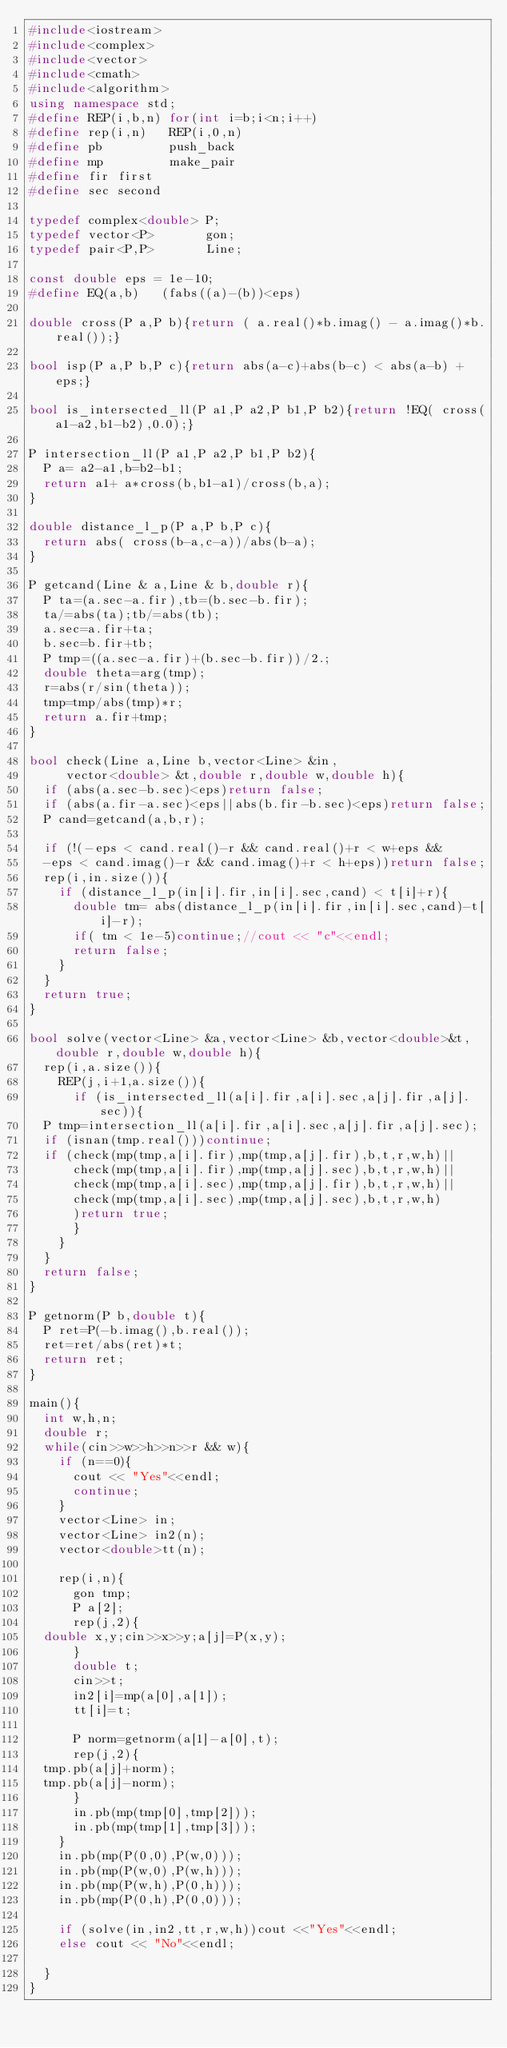<code> <loc_0><loc_0><loc_500><loc_500><_C++_>#include<iostream>
#include<complex>
#include<vector>
#include<cmath>
#include<algorithm>
using namespace std;
#define REP(i,b,n) for(int i=b;i<n;i++)
#define rep(i,n)   REP(i,0,n)
#define pb         push_back
#define mp         make_pair
#define fir first
#define sec second

typedef complex<double> P;
typedef vector<P>       gon;
typedef pair<P,P>       Line;

const double eps = 1e-10;
#define EQ(a,b)   (fabs((a)-(b))<eps)

double cross(P a,P b){return ( a.real()*b.imag() - a.imag()*b.real());}

bool isp(P a,P b,P c){return abs(a-c)+abs(b-c) < abs(a-b) + eps;}

bool is_intersected_ll(P a1,P a2,P b1,P b2){return !EQ( cross(a1-a2,b1-b2),0.0);}

P intersection_ll(P a1,P a2,P b1,P b2){
  P a= a2-a1,b=b2-b1;
  return a1+ a*cross(b,b1-a1)/cross(b,a);
}

double distance_l_p(P a,P b,P c){
  return abs( cross(b-a,c-a))/abs(b-a);
}

P getcand(Line & a,Line & b,double r){
  P ta=(a.sec-a.fir),tb=(b.sec-b.fir);
  ta/=abs(ta);tb/=abs(tb);
  a.sec=a.fir+ta;
  b.sec=b.fir+tb;
  P tmp=((a.sec-a.fir)+(b.sec-b.fir))/2.;
  double theta=arg(tmp);
  r=abs(r/sin(theta));
  tmp=tmp/abs(tmp)*r;
  return a.fir+tmp;
}

bool check(Line a,Line b,vector<Line> &in,
	   vector<double> &t,double r,double w,double h){
  if (abs(a.sec-b.sec)<eps)return false;
  if (abs(a.fir-a.sec)<eps||abs(b.fir-b.sec)<eps)return false;
  P cand=getcand(a,b,r);

  if (!(-eps < cand.real()-r && cand.real()+r < w+eps &&
	-eps < cand.imag()-r && cand.imag()+r < h+eps))return false;
  rep(i,in.size()){
    if (distance_l_p(in[i].fir,in[i].sec,cand) < t[i]+r){
      double tm= abs(distance_l_p(in[i].fir,in[i].sec,cand)-t[i]-r);
      if( tm < 1e-5)continue;//cout << "c"<<endl;
      return false;
    }
  }
  return true;
}

bool solve(vector<Line> &a,vector<Line> &b,vector<double>&t,double r,double w,double h){
  rep(i,a.size()){
    REP(j,i+1,a.size()){
      if (is_intersected_ll(a[i].fir,a[i].sec,a[j].fir,a[j].sec)){
	P tmp=intersection_ll(a[i].fir,a[i].sec,a[j].fir,a[j].sec);
	if (isnan(tmp.real()))continue;
	if (check(mp(tmp,a[i].fir),mp(tmp,a[j].fir),b,t,r,w,h)||
	    check(mp(tmp,a[i].fir),mp(tmp,a[j].sec),b,t,r,w,h)||
	    check(mp(tmp,a[i].sec),mp(tmp,a[j].fir),b,t,r,w,h)||
	    check(mp(tmp,a[i].sec),mp(tmp,a[j].sec),b,t,r,w,h)
	    )return true;
      }
    }
  }
  return false;
}

P getnorm(P b,double t){
  P ret=P(-b.imag(),b.real());
  ret=ret/abs(ret)*t;
  return ret;
}

main(){
  int w,h,n;
  double r;
  while(cin>>w>>h>>n>>r && w){
    if (n==0){
      cout << "Yes"<<endl;
      continue;
    }
    vector<Line> in;
    vector<Line> in2(n);
    vector<double>tt(n);

    rep(i,n){
      gon tmp;
      P a[2];
      rep(j,2){
	double x,y;cin>>x>>y;a[j]=P(x,y);
      }
      double t;
      cin>>t;
      in2[i]=mp(a[0],a[1]);
      tt[i]=t;

      P norm=getnorm(a[1]-a[0],t);
      rep(j,2){
	tmp.pb(a[j]+norm);
	tmp.pb(a[j]-norm);
      }
      in.pb(mp(tmp[0],tmp[2]));
      in.pb(mp(tmp[1],tmp[3]));
    }
    in.pb(mp(P(0,0),P(w,0)));
    in.pb(mp(P(w,0),P(w,h)));
    in.pb(mp(P(w,h),P(0,h)));
    in.pb(mp(P(0,h),P(0,0)));

    if (solve(in,in2,tt,r,w,h))cout <<"Yes"<<endl;
    else cout << "No"<<endl;

  }
}</code> 